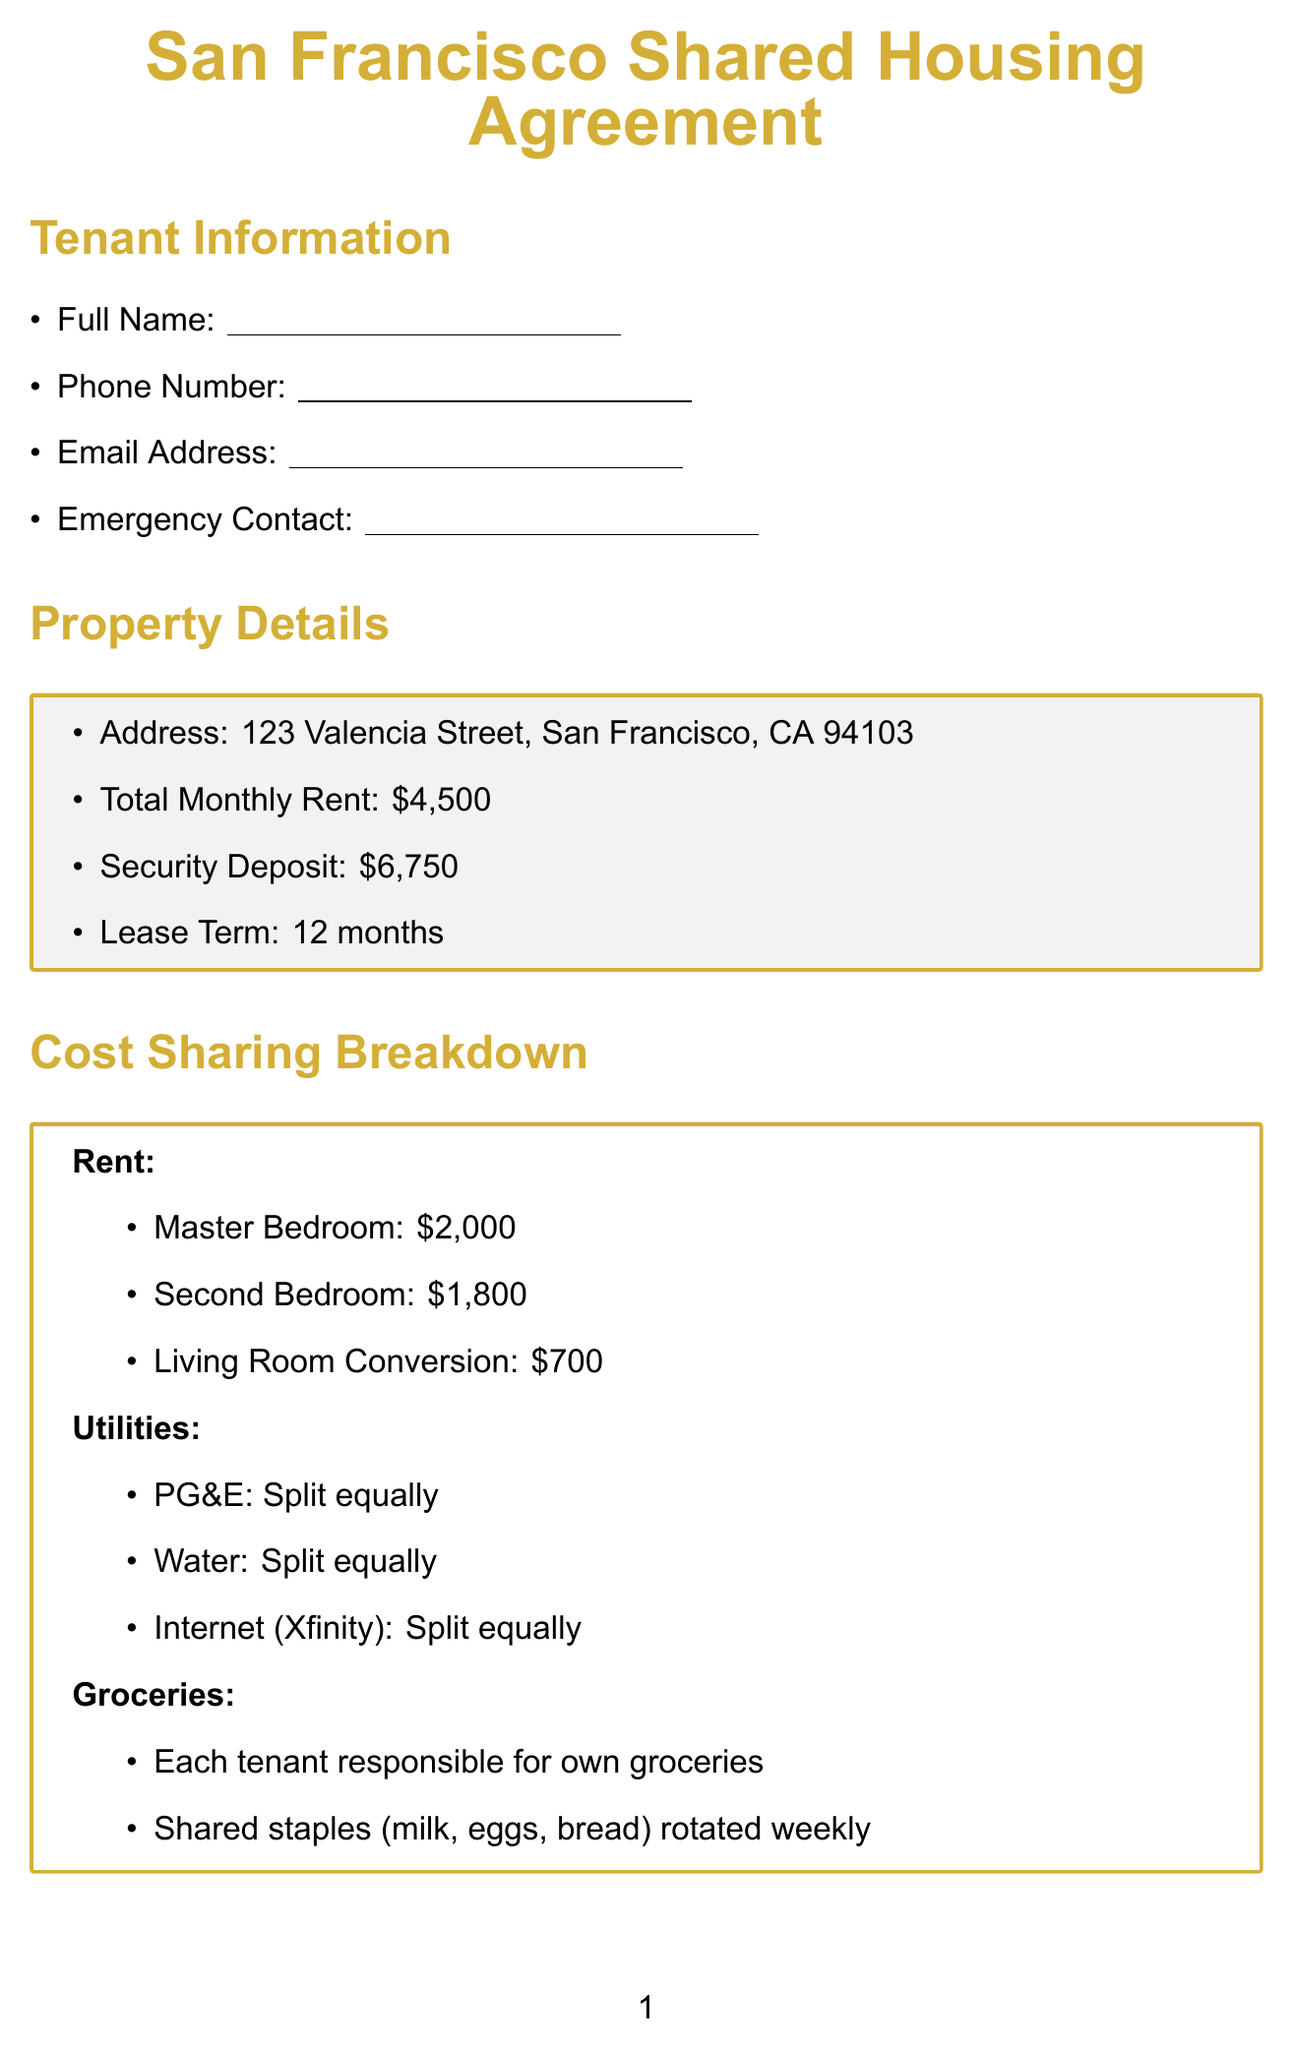What is the total monthly rent? The total monthly rent is mentioned in the Property Details section of the document.
Answer: $4,500 What is the security deposit amount? The security deposit is specified in the Property Details section of the document.
Answer: $6,750 How much is the rent for the Master Bedroom? The rent for the Master Bedroom is provided in the Cost Sharing Breakdown section under Rent.
Answer: $2,000 What is the cleaning schedule according to the house rules? The house rules detail the responsibilities related to maintaining cleanliness in shared areas.
Answer: Rotating weekly duties What is the maximum annual rent increase allowed? The additional clauses outline the annual rent increase limitations set by regulations.
Answer: 7% Which resources are listed for tenant assistance? Local resources are provided at the end of the document for tenant support.
Answer: San Francisco Tenants Union: sftu.org How is the cost of groceries shared among tenants? The Cost Sharing Breakdown section discusses the responsibilities concerning groceries.
Answer: Each tenant responsible for own groceries What happens if a conflict arises between tenants? The Conflict Resolution section describes the steps to resolve disputes among tenants.
Answer: Direct communication between involved parties Are pets allowed in the apartment? The house rules outline the policy on pets, indicating what types are allowed.
Answer: Only pre-approved emotional support animals allowed 